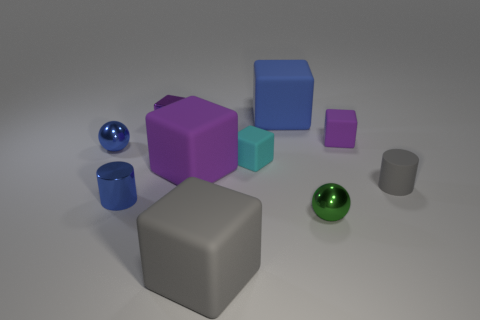What number of other things are the same size as the purple metallic block?
Your answer should be compact. 6. How many objects are either matte things that are behind the big gray object or tiny blue things in front of the gray cylinder?
Offer a terse response. 6. Does the small cyan block have the same material as the ball that is in front of the blue metallic sphere?
Offer a terse response. No. What number of other things are the same shape as the green metallic thing?
Your answer should be very brief. 1. What material is the tiny purple block on the right side of the large matte cube that is in front of the small thing that is right of the small purple rubber cube made of?
Your answer should be very brief. Rubber. Are there an equal number of large purple rubber blocks that are to the right of the small gray cylinder and gray cylinders?
Offer a terse response. No. Is the tiny cylinder that is on the right side of the small green metal thing made of the same material as the gray object in front of the gray matte cylinder?
Your answer should be compact. Yes. Is there any other thing that is made of the same material as the tiny green sphere?
Your response must be concise. Yes. Is the shape of the big thing that is right of the large gray thing the same as the gray matte object that is right of the tiny cyan rubber object?
Keep it short and to the point. No. Is the number of blue rubber things that are right of the green metallic sphere less than the number of small metal cubes?
Give a very brief answer. Yes. 